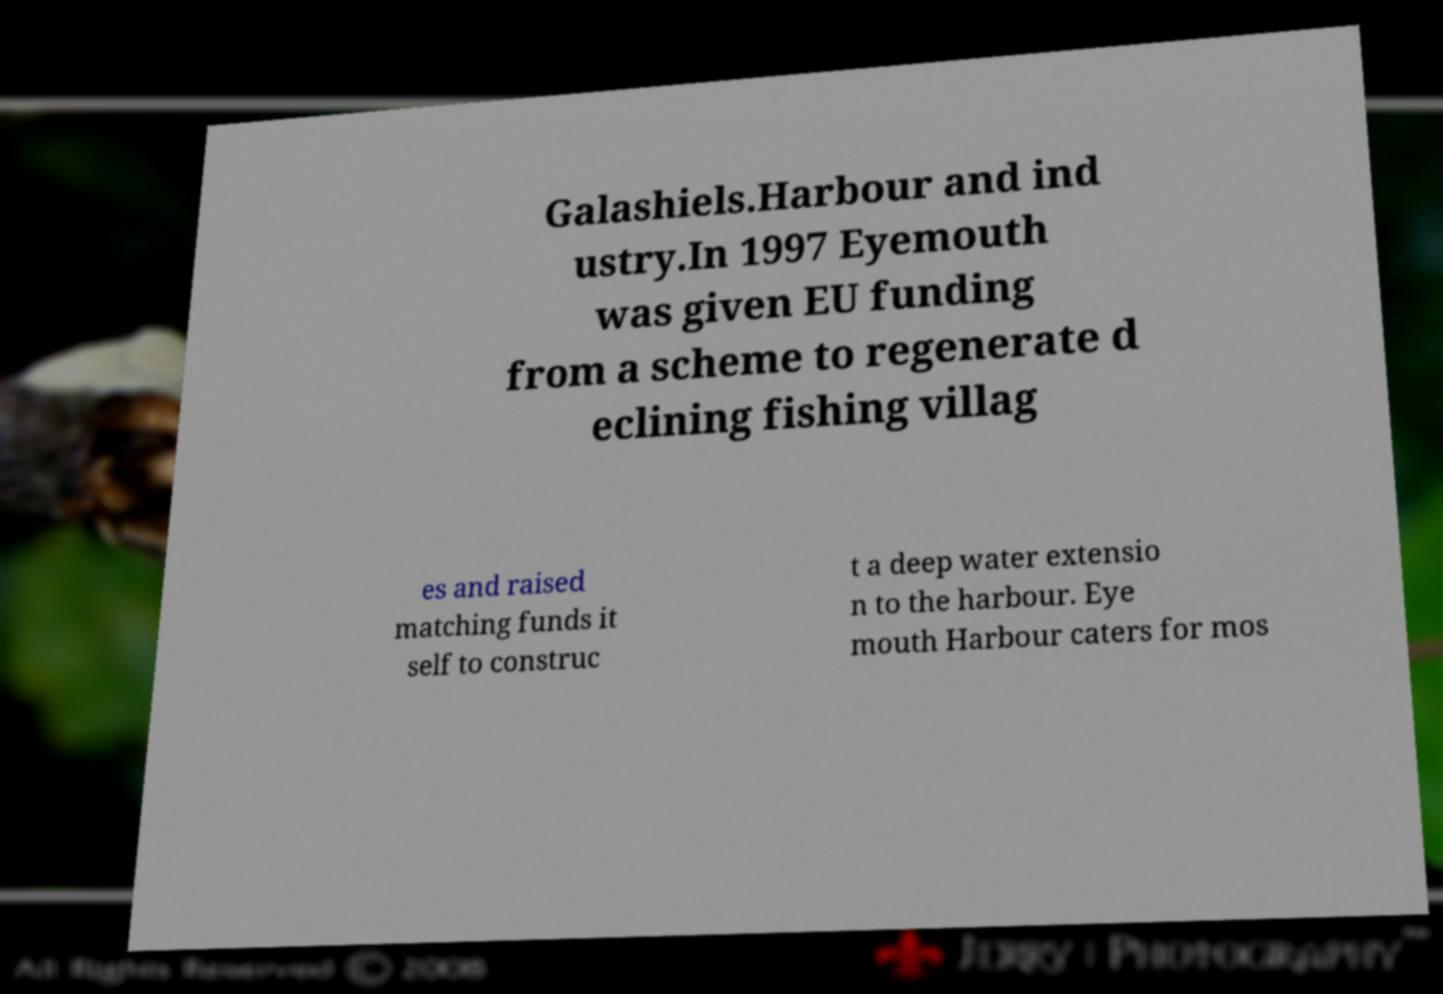I need the written content from this picture converted into text. Can you do that? Galashiels.Harbour and ind ustry.In 1997 Eyemouth was given EU funding from a scheme to regenerate d eclining fishing villag es and raised matching funds it self to construc t a deep water extensio n to the harbour. Eye mouth Harbour caters for mos 